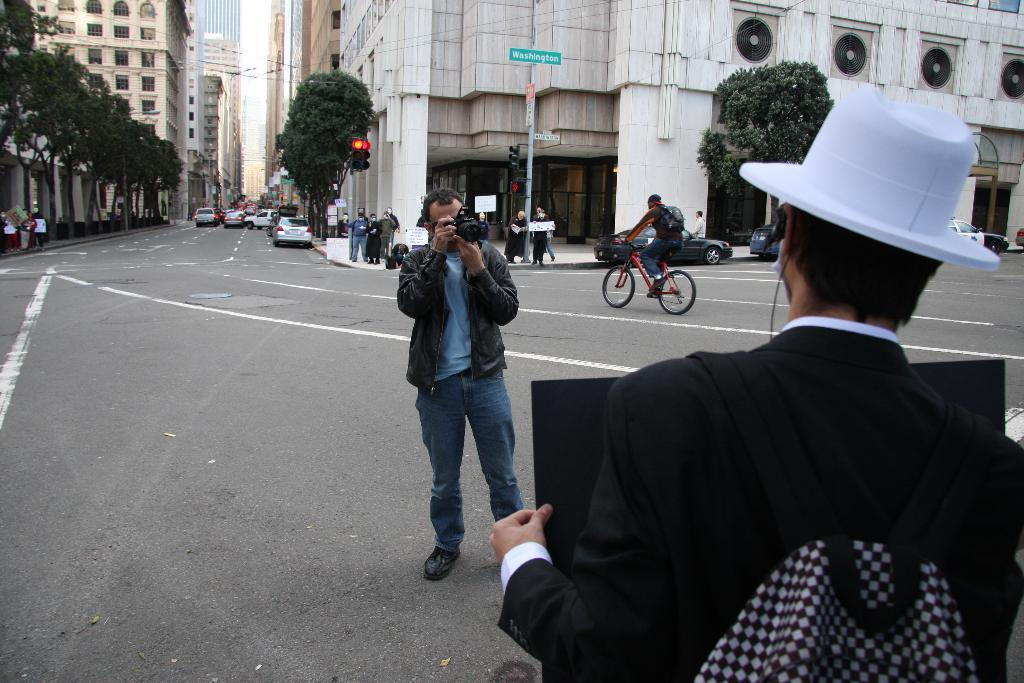Who or what can be seen in the image? There are people in the image. What type of structures are visible in the image? There are buildings in the image. What is the surface that the people, buildings, and other objects are situated on? The ground is visible in the image. Are there any objects placed on the ground? Yes, there are objects on the ground. What else can be seen moving in the image? There are vehicles in the image. Are there any signs or notices in the image? Yes, there are boards with text in the image. What type of natural elements can be seen in the image? There are trees in the image. Are there any vertical structures in the image? Yes, there are poles in the image. Where is the throne located in the image? There is no throne present in the image. What type of land is visible in the image? The term "land" is not mentioned in the facts provided, and the image does not depict a specific type of land. What kind of bait is used in the image? There is no mention of bait in the image or the provided facts. 